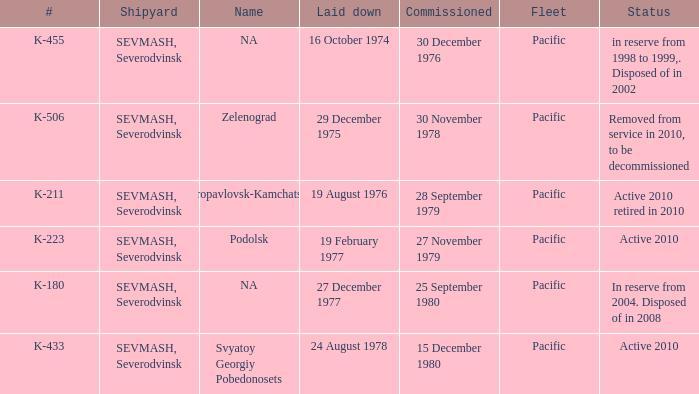What is the status of vessel number K-223? Active 2010. Would you mind parsing the complete table? {'header': ['#', 'Shipyard', 'Name', 'Laid down', 'Commissioned', 'Fleet', 'Status'], 'rows': [['K-455', 'SEVMASH, Severodvinsk', 'NA', '16 October 1974', '30 December 1976', 'Pacific', 'in reserve from 1998 to 1999,. Disposed of in 2002'], ['K-506', 'SEVMASH, Severodvinsk', 'Zelenograd', '29 December 1975', '30 November 1978', 'Pacific', 'Removed from service in 2010, to be decommissioned'], ['K-211', 'SEVMASH, Severodvinsk', 'Petropavlovsk-Kamchatskiy', '19 August 1976', '28 September 1979', 'Pacific', 'Active 2010 retired in 2010'], ['K-223', 'SEVMASH, Severodvinsk', 'Podolsk', '19 February 1977', '27 November 1979', 'Pacific', 'Active 2010'], ['K-180', 'SEVMASH, Severodvinsk', 'NA', '27 December 1977', '25 September 1980', 'Pacific', 'In reserve from 2004. Disposed of in 2008'], ['K-433', 'SEVMASH, Severodvinsk', 'Svyatoy Georgiy Pobedonosets', '24 August 1978', '15 December 1980', 'Pacific', 'Active 2010']]} 